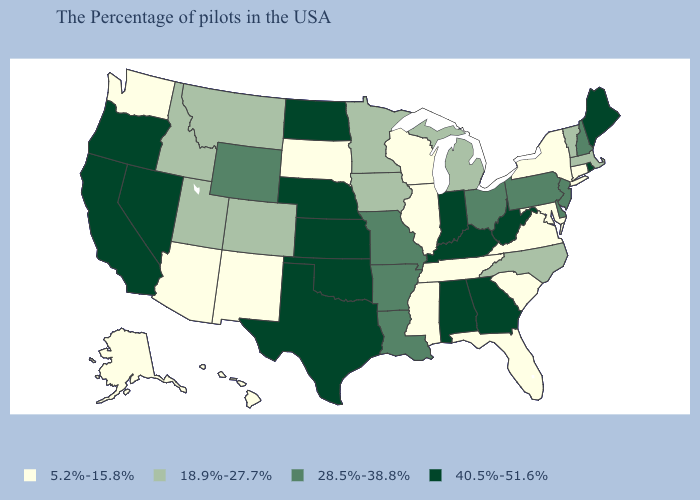Name the states that have a value in the range 28.5%-38.8%?
Concise answer only. New Hampshire, New Jersey, Delaware, Pennsylvania, Ohio, Louisiana, Missouri, Arkansas, Wyoming. Does New Jersey have the lowest value in the USA?
Short answer required. No. How many symbols are there in the legend?
Keep it brief. 4. What is the value of Iowa?
Write a very short answer. 18.9%-27.7%. Which states have the lowest value in the MidWest?
Be succinct. Wisconsin, Illinois, South Dakota. Which states hav the highest value in the West?
Quick response, please. Nevada, California, Oregon. What is the value of South Carolina?
Concise answer only. 5.2%-15.8%. Which states hav the highest value in the West?
Concise answer only. Nevada, California, Oregon. Which states have the highest value in the USA?
Write a very short answer. Maine, Rhode Island, West Virginia, Georgia, Kentucky, Indiana, Alabama, Kansas, Nebraska, Oklahoma, Texas, North Dakota, Nevada, California, Oregon. What is the value of Rhode Island?
Quick response, please. 40.5%-51.6%. Does the first symbol in the legend represent the smallest category?
Answer briefly. Yes. Which states have the lowest value in the USA?
Short answer required. Connecticut, New York, Maryland, Virginia, South Carolina, Florida, Tennessee, Wisconsin, Illinois, Mississippi, South Dakota, New Mexico, Arizona, Washington, Alaska, Hawaii. Name the states that have a value in the range 5.2%-15.8%?
Quick response, please. Connecticut, New York, Maryland, Virginia, South Carolina, Florida, Tennessee, Wisconsin, Illinois, Mississippi, South Dakota, New Mexico, Arizona, Washington, Alaska, Hawaii. Which states have the lowest value in the USA?
Short answer required. Connecticut, New York, Maryland, Virginia, South Carolina, Florida, Tennessee, Wisconsin, Illinois, Mississippi, South Dakota, New Mexico, Arizona, Washington, Alaska, Hawaii. Name the states that have a value in the range 28.5%-38.8%?
Give a very brief answer. New Hampshire, New Jersey, Delaware, Pennsylvania, Ohio, Louisiana, Missouri, Arkansas, Wyoming. 